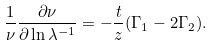<formula> <loc_0><loc_0><loc_500><loc_500>\frac { 1 } { \nu } \frac { \partial \nu } { \partial \ln \lambda ^ { - 1 } } = - \frac { t } { z } ( \Gamma _ { 1 } - 2 \Gamma _ { 2 } ) .</formula> 